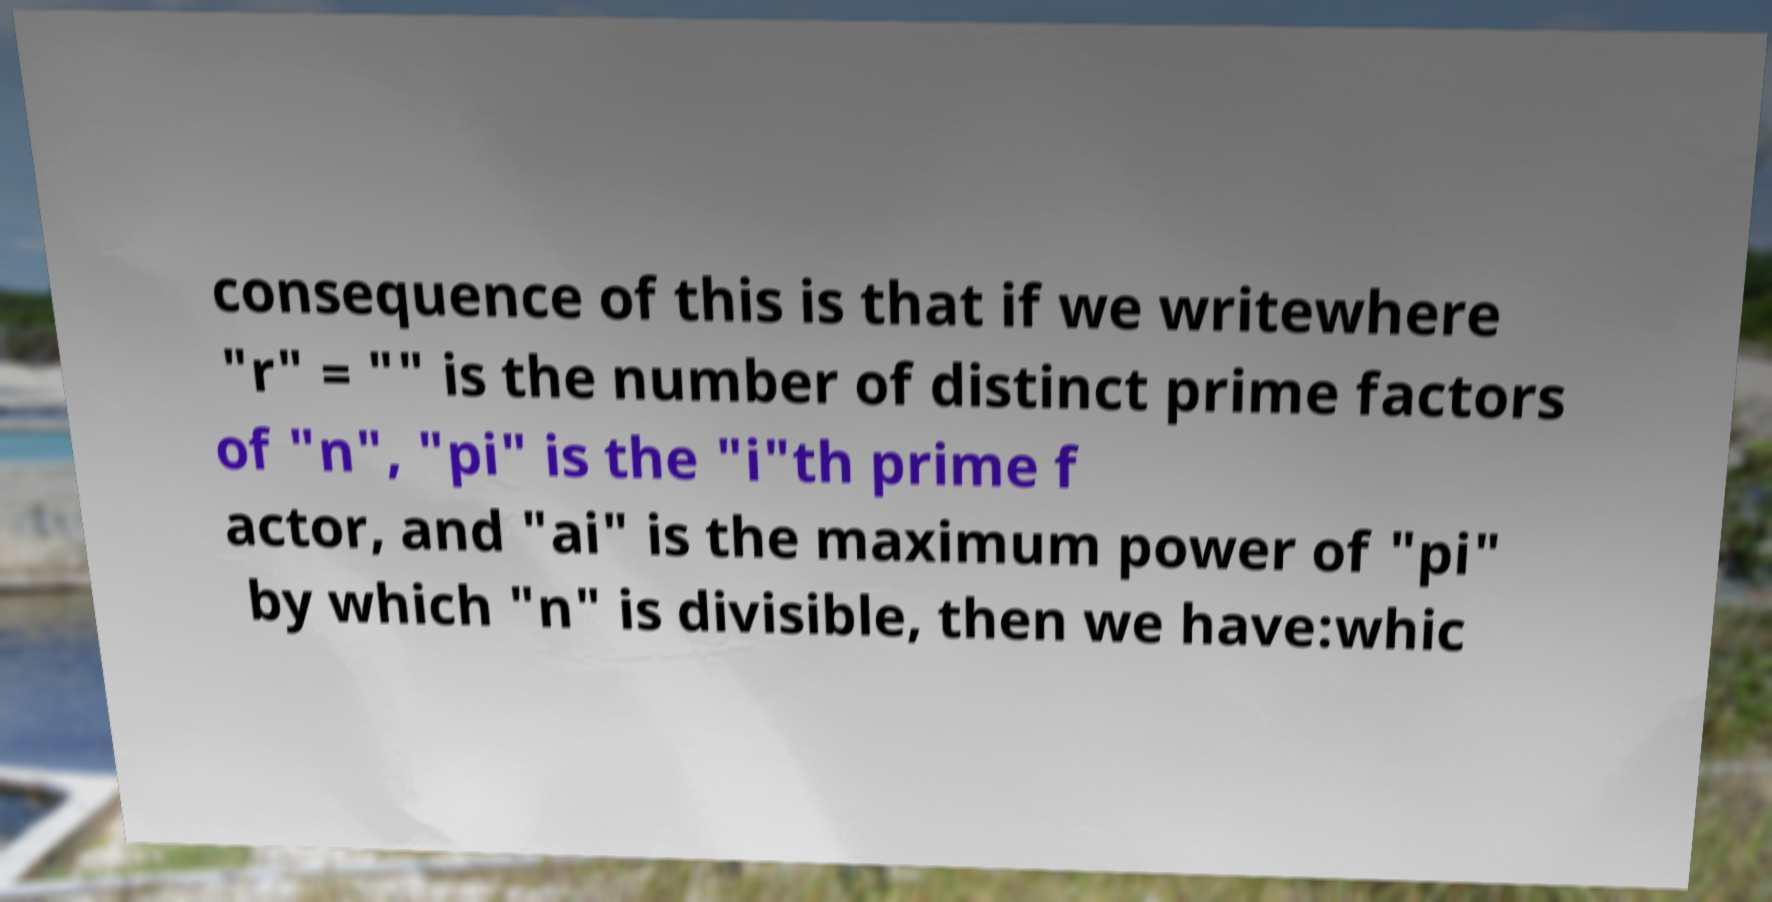I need the written content from this picture converted into text. Can you do that? consequence of this is that if we writewhere "r" = "" is the number of distinct prime factors of "n", "pi" is the "i"th prime f actor, and "ai" is the maximum power of "pi" by which "n" is divisible, then we have:whic 